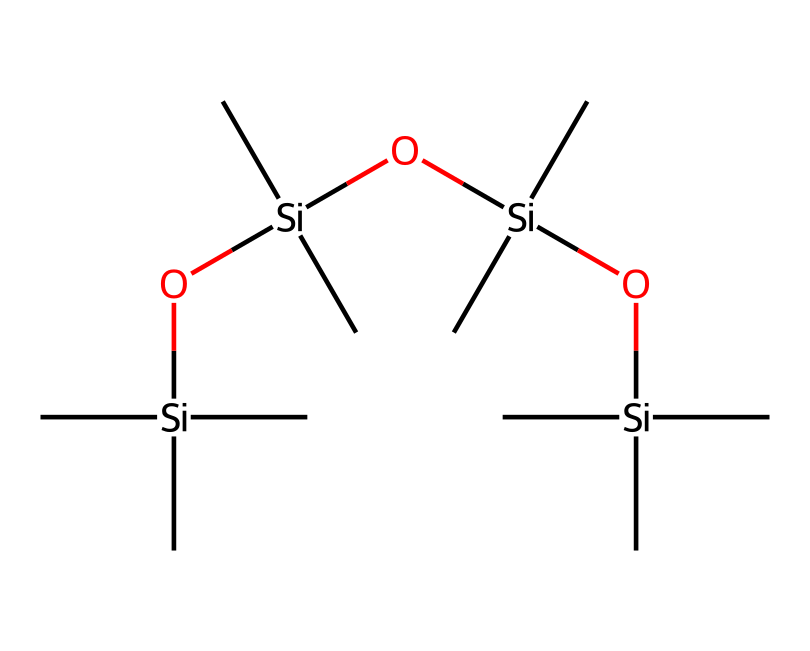how many silicon atoms are present in the structure? The SMILES notation shows a repeating unit of [Si], and upon counting each occurrence, we find there are four silicon atoms.
Answer: four what is the main functional group in this compound? From the SMILES, we observe the presence of -O- linkages, indicating that the main functional group is siloxane.
Answer: siloxane how many carbon atoms are in the compound? The structure features multiple occurrences of 'C' in the SMILES representation; by counting each 'C', we ascertain there are 12 carbon atoms total.
Answer: twelve what is the logical bonding pattern displayed in the compound? The pattern consists of alternating silicon and oxygen atoms; each silicon atom connects to two carbon atoms and one oxygen atom, forming a linear siloxane structure.
Answer: alternating silicon and oxygen does this compound have hydrophilic or hydrophobic properties? Based on the molecular structure dominated by silicon and carbon, it exhibits hydrophobic characteristics due to the predominance of non-polar carbon-silicon bonds.
Answer: hydrophobic what type of applications can this compound be used for? Given the siloxane structure and properties, it is commonly utilized in lubricants for reducing friction in joints, particularly for athletes.
Answer: lubricants what does the repeating Si-O linkage indicate about the compound's flexibility? The Si-O bond is known for providing flexibility and resilience in organosilicon compounds, allowing this lubricant to maintain performance under dynamic conditions.
Answer: flexibility 